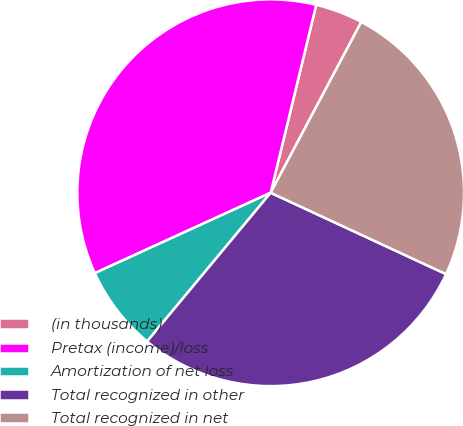Convert chart. <chart><loc_0><loc_0><loc_500><loc_500><pie_chart><fcel>(in thousands)<fcel>Pretax (income)/loss<fcel>Amortization of net loss<fcel>Total recognized in other<fcel>Total recognized in net<nl><fcel>3.98%<fcel>35.61%<fcel>7.14%<fcel>29.12%<fcel>24.15%<nl></chart> 